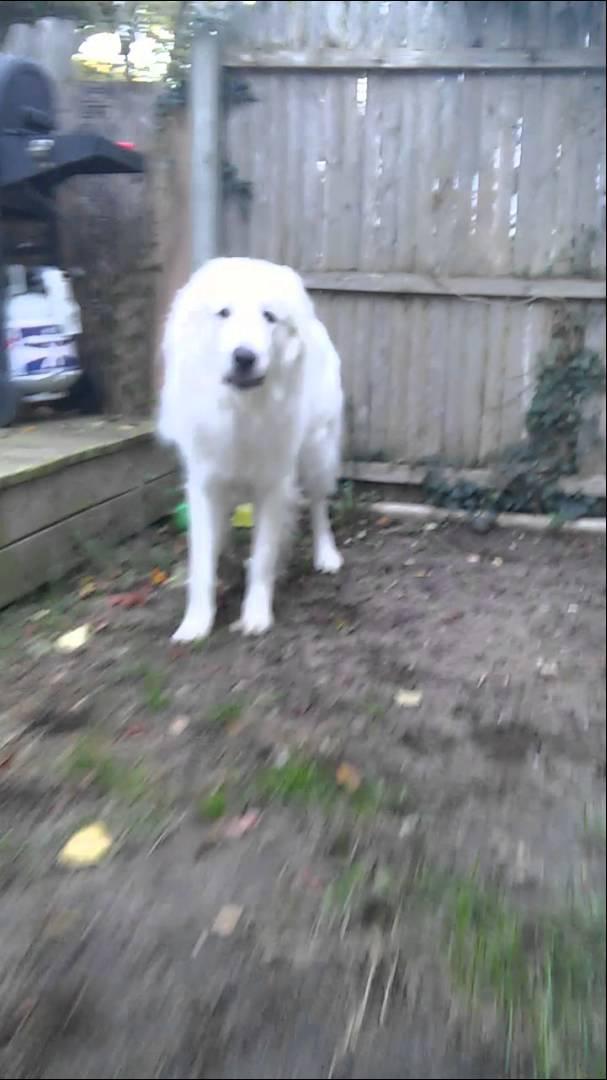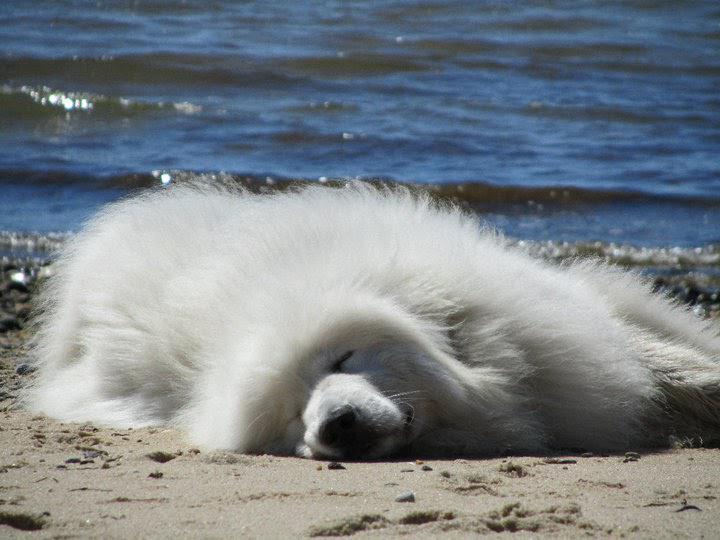The first image is the image on the left, the second image is the image on the right. Given the left and right images, does the statement "An image shows a dog running across the grass with its tongue sticking out and to one side." hold true? Answer yes or no. No. The first image is the image on the left, the second image is the image on the right. Examine the images to the left and right. Is the description "The dog in the image on the left is running through the grass." accurate? Answer yes or no. No. 